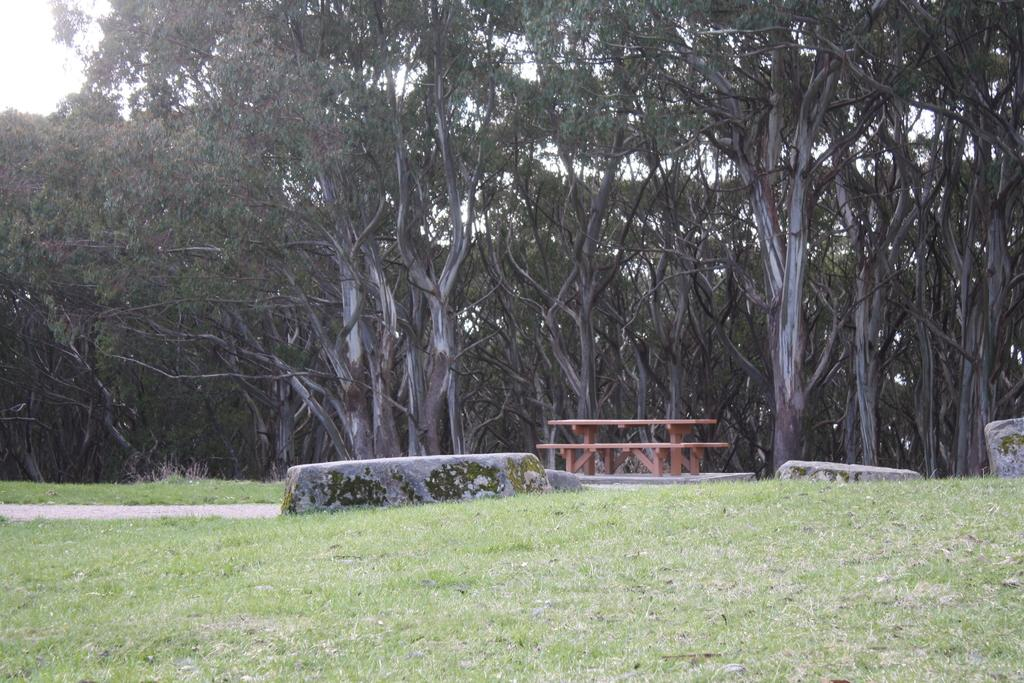What type of seating is visible in the image? There is a bench in the image. What other objects can be seen on the ground in the image? There are stones visible on the ground in the image. What type of vegetation is present on the ground in the image? Grass is present on the ground in the image. What can be seen in the background of the image? There are trees and the sky visible in the background of the image. What type of fowl is present in the image? There is no fowl present in the image. What type of plants are growing on the bench in the image? There are no plants growing on the bench in the image; only a bench, stones, grass, trees, and the sky are visible. 